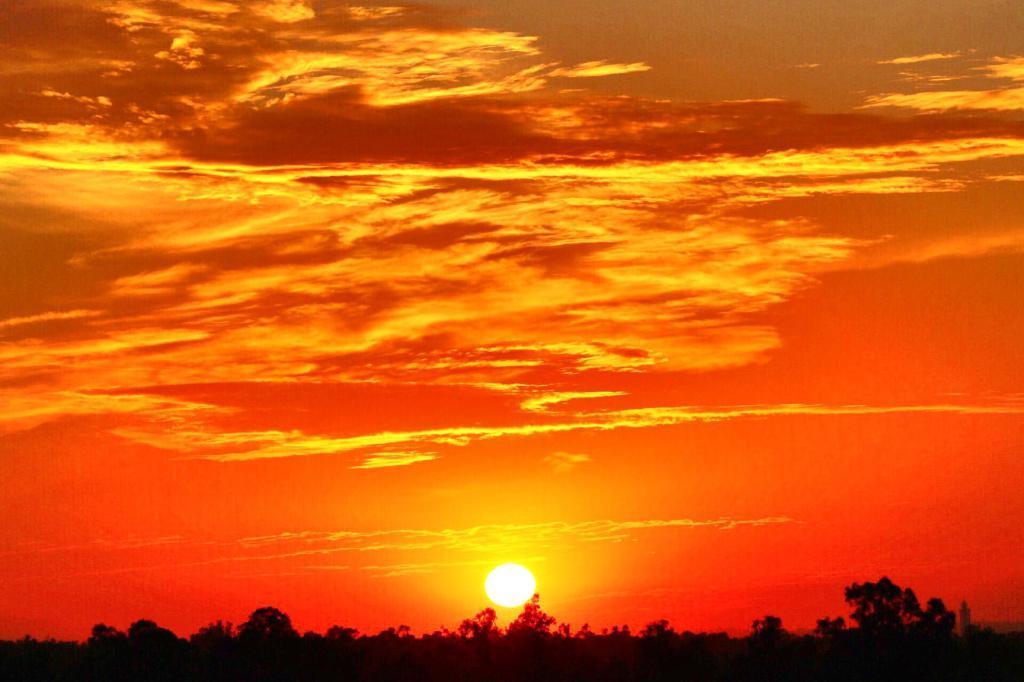Could you give a brief overview of what you see in this image? This image is taken outdoors. In the background there is a sky with clouds and sun. The sky is orange in color. At the bottom of the image there are a few trees and plants. 